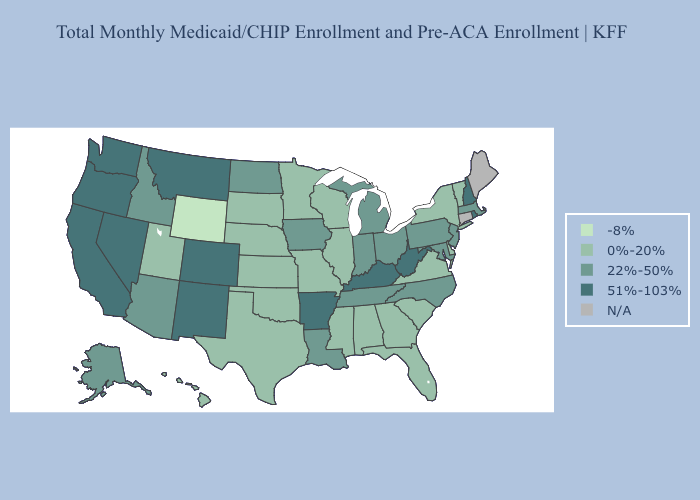Name the states that have a value in the range 51%-103%?
Short answer required. Arkansas, California, Colorado, Kentucky, Montana, Nevada, New Hampshire, New Mexico, Oregon, Rhode Island, Washington, West Virginia. What is the highest value in the South ?
Answer briefly. 51%-103%. What is the lowest value in the Northeast?
Short answer required. 0%-20%. What is the value of Colorado?
Keep it brief. 51%-103%. What is the lowest value in states that border Maine?
Keep it brief. 51%-103%. Among the states that border Michigan , does Indiana have the lowest value?
Quick response, please. No. Does Georgia have the lowest value in the USA?
Answer briefly. No. Does the map have missing data?
Write a very short answer. Yes. What is the highest value in the South ?
Short answer required. 51%-103%. Name the states that have a value in the range 22%-50%?
Quick response, please. Alaska, Arizona, Idaho, Indiana, Iowa, Louisiana, Maryland, Massachusetts, Michigan, New Jersey, North Carolina, North Dakota, Ohio, Pennsylvania, Tennessee. What is the value of Texas?
Give a very brief answer. 0%-20%. Which states hav the highest value in the South?
Be succinct. Arkansas, Kentucky, West Virginia. Does the map have missing data?
Write a very short answer. Yes. What is the lowest value in the USA?
Be succinct. -8%. 